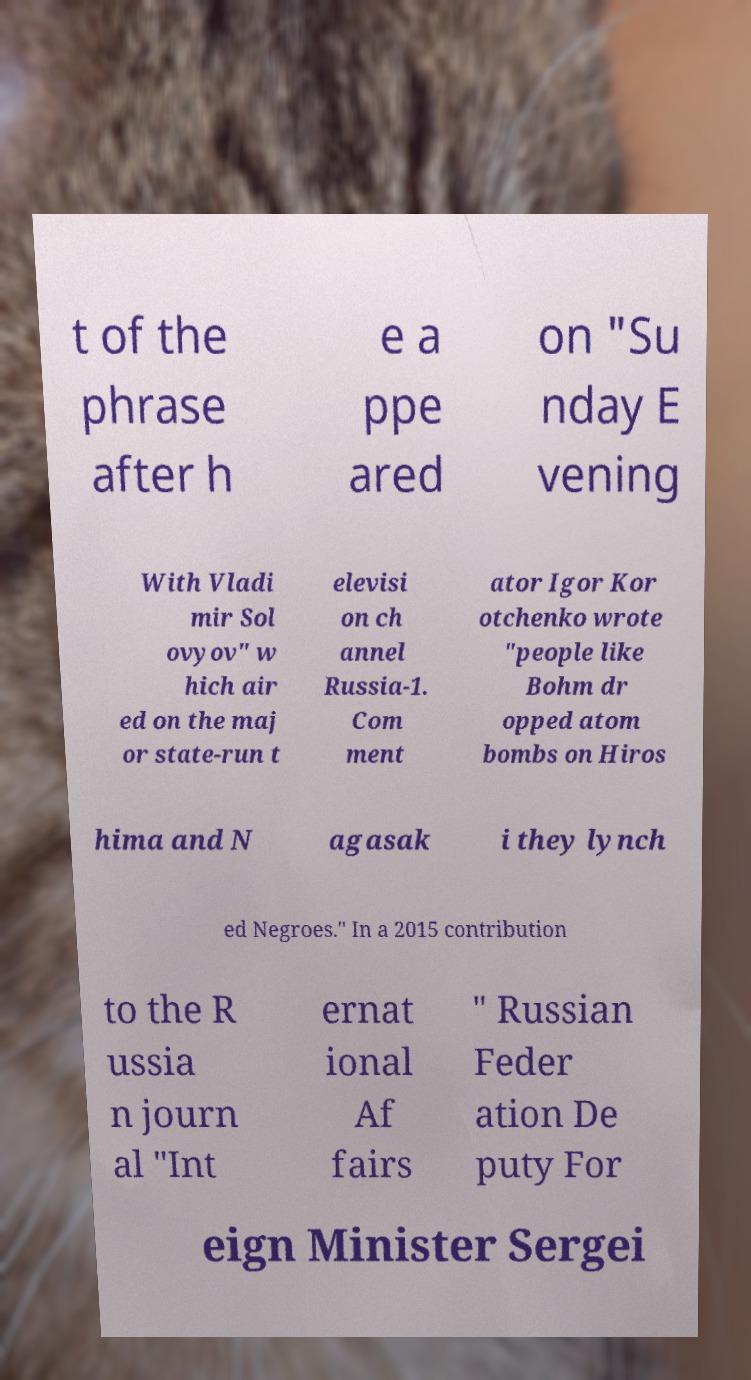Can you accurately transcribe the text from the provided image for me? t of the phrase after h e a ppe ared on "Su nday E vening With Vladi mir Sol ovyov" w hich air ed on the maj or state-run t elevisi on ch annel Russia-1. Com ment ator Igor Kor otchenko wrote "people like Bohm dr opped atom bombs on Hiros hima and N agasak i they lynch ed Negroes." In a 2015 contribution to the R ussia n journ al "Int ernat ional Af fairs " Russian Feder ation De puty For eign Minister Sergei 